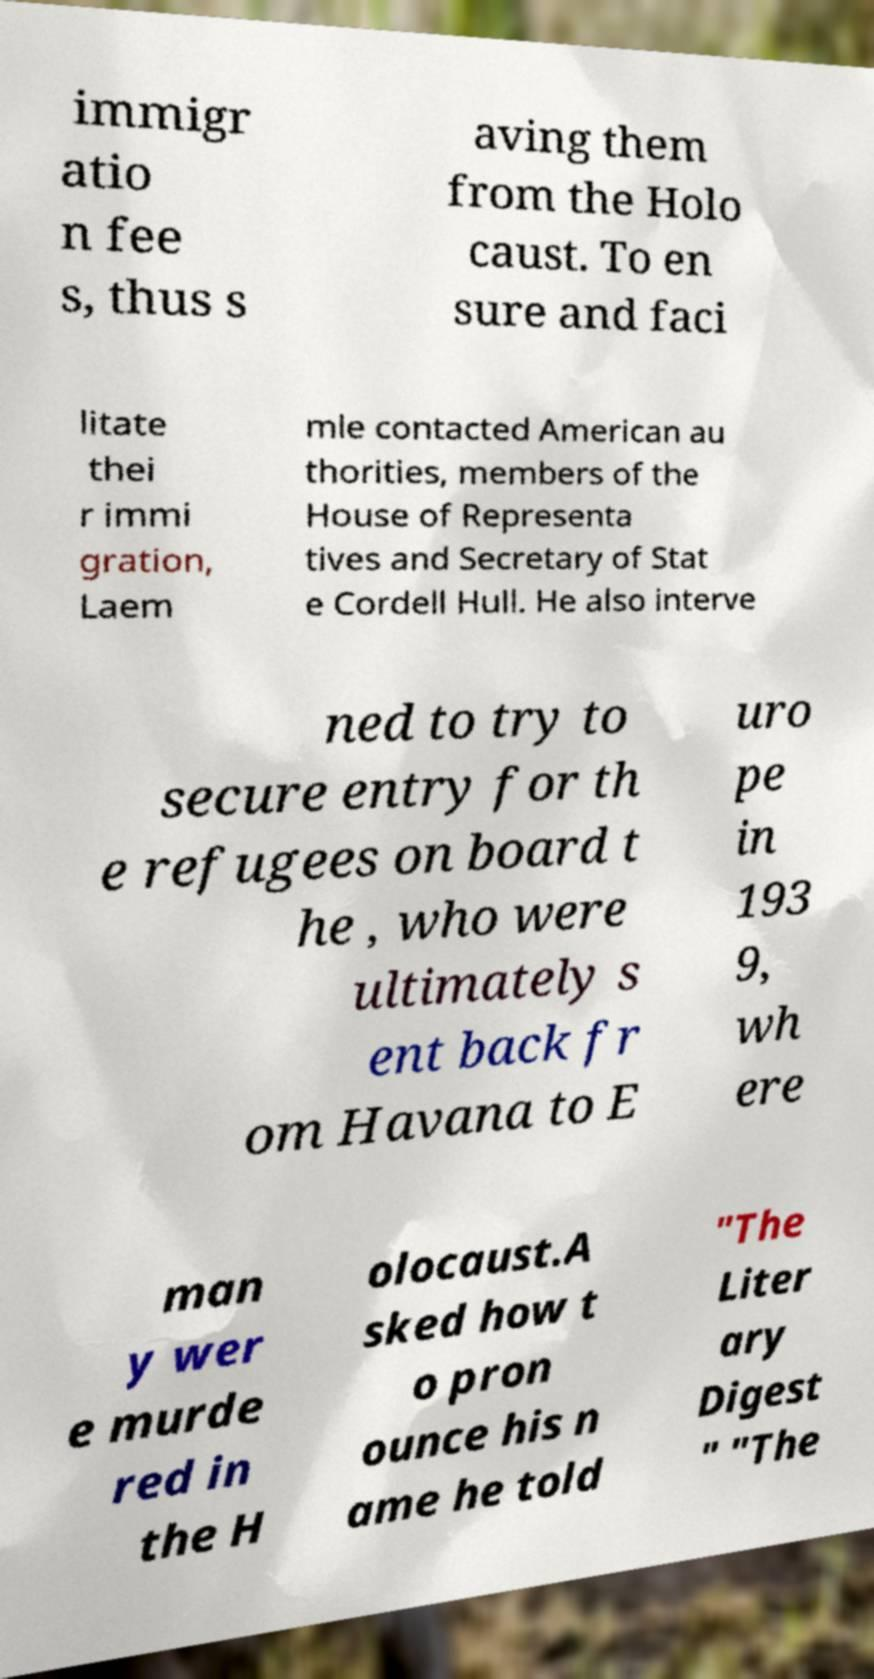Could you assist in decoding the text presented in this image and type it out clearly? immigr atio n fee s, thus s aving them from the Holo caust. To en sure and faci litate thei r immi gration, Laem mle contacted American au thorities, members of the House of Representa tives and Secretary of Stat e Cordell Hull. He also interve ned to try to secure entry for th e refugees on board t he , who were ultimately s ent back fr om Havana to E uro pe in 193 9, wh ere man y wer e murde red in the H olocaust.A sked how t o pron ounce his n ame he told "The Liter ary Digest " "The 